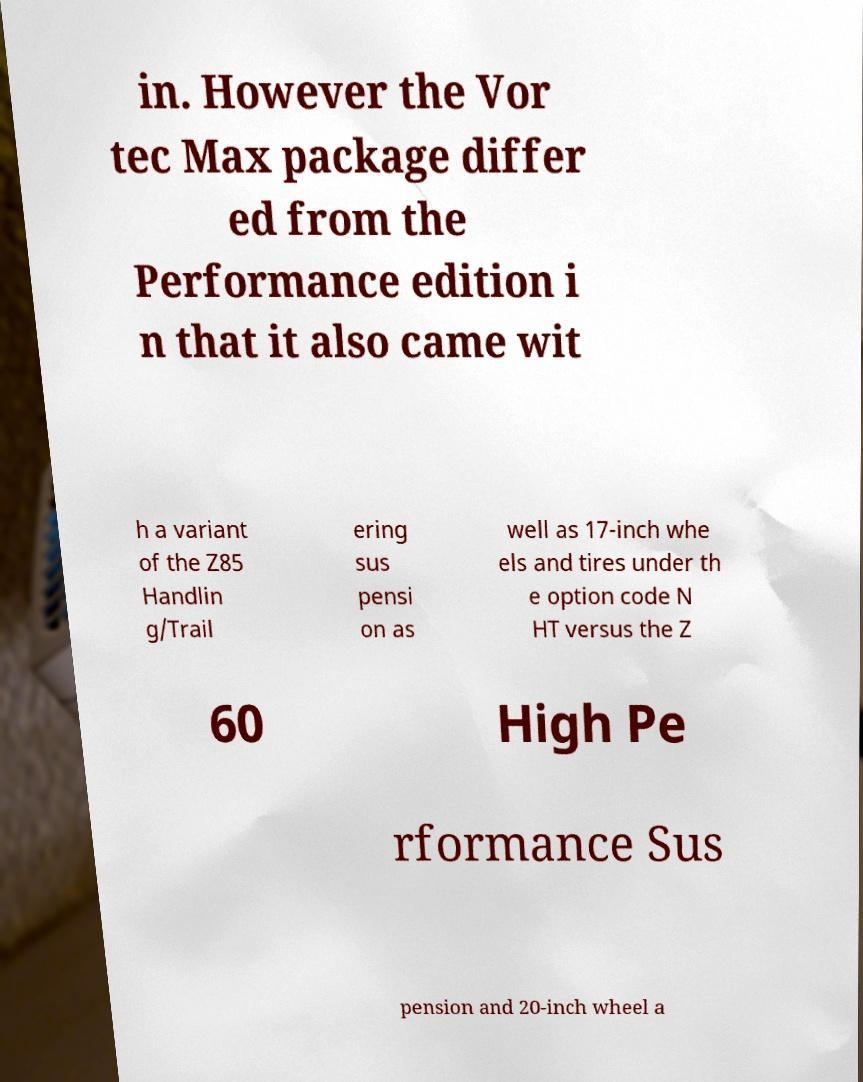There's text embedded in this image that I need extracted. Can you transcribe it verbatim? in. However the Vor tec Max package differ ed from the Performance edition i n that it also came wit h a variant of the Z85 Handlin g/Trail ering sus pensi on as well as 17-inch whe els and tires under th e option code N HT versus the Z 60 High Pe rformance Sus pension and 20-inch wheel a 